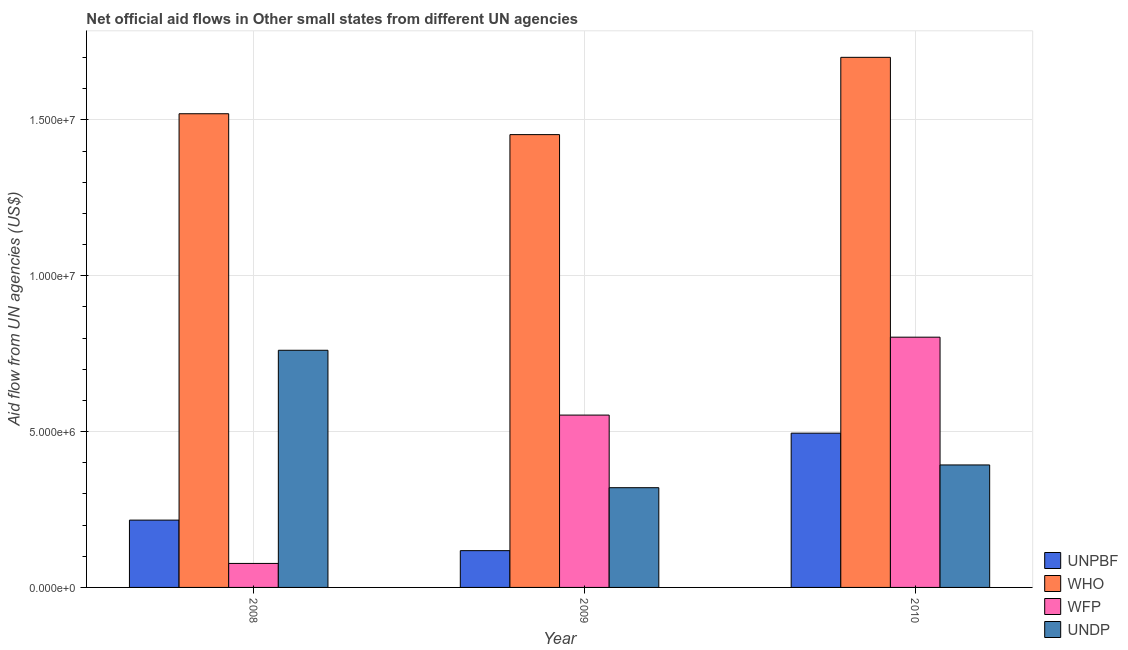Are the number of bars per tick equal to the number of legend labels?
Make the answer very short. Yes. Are the number of bars on each tick of the X-axis equal?
Provide a short and direct response. Yes. How many bars are there on the 2nd tick from the right?
Provide a short and direct response. 4. What is the label of the 3rd group of bars from the left?
Your response must be concise. 2010. What is the amount of aid given by wfp in 2010?
Make the answer very short. 8.03e+06. Across all years, what is the maximum amount of aid given by undp?
Provide a succinct answer. 7.61e+06. Across all years, what is the minimum amount of aid given by unpbf?
Ensure brevity in your answer.  1.18e+06. What is the total amount of aid given by who in the graph?
Offer a very short reply. 4.67e+07. What is the difference between the amount of aid given by undp in 2009 and that in 2010?
Ensure brevity in your answer.  -7.30e+05. What is the difference between the amount of aid given by unpbf in 2008 and the amount of aid given by wfp in 2010?
Keep it short and to the point. -2.79e+06. What is the average amount of aid given by wfp per year?
Keep it short and to the point. 4.78e+06. In the year 2009, what is the difference between the amount of aid given by who and amount of aid given by wfp?
Give a very brief answer. 0. What is the ratio of the amount of aid given by undp in 2008 to that in 2009?
Your answer should be very brief. 2.38. Is the amount of aid given by who in 2009 less than that in 2010?
Your answer should be very brief. Yes. Is the difference between the amount of aid given by wfp in 2009 and 2010 greater than the difference between the amount of aid given by who in 2009 and 2010?
Your answer should be very brief. No. What is the difference between the highest and the second highest amount of aid given by unpbf?
Your answer should be very brief. 2.79e+06. What is the difference between the highest and the lowest amount of aid given by unpbf?
Your answer should be very brief. 3.77e+06. In how many years, is the amount of aid given by undp greater than the average amount of aid given by undp taken over all years?
Provide a short and direct response. 1. What does the 1st bar from the left in 2010 represents?
Keep it short and to the point. UNPBF. What does the 2nd bar from the right in 2009 represents?
Your response must be concise. WFP. Is it the case that in every year, the sum of the amount of aid given by unpbf and amount of aid given by who is greater than the amount of aid given by wfp?
Keep it short and to the point. Yes. How many bars are there?
Offer a very short reply. 12. Are all the bars in the graph horizontal?
Your response must be concise. No. How many years are there in the graph?
Give a very brief answer. 3. Are the values on the major ticks of Y-axis written in scientific E-notation?
Your response must be concise. Yes. What is the title of the graph?
Offer a terse response. Net official aid flows in Other small states from different UN agencies. What is the label or title of the Y-axis?
Give a very brief answer. Aid flow from UN agencies (US$). What is the Aid flow from UN agencies (US$) in UNPBF in 2008?
Your answer should be compact. 2.16e+06. What is the Aid flow from UN agencies (US$) of WHO in 2008?
Give a very brief answer. 1.52e+07. What is the Aid flow from UN agencies (US$) of WFP in 2008?
Your answer should be compact. 7.70e+05. What is the Aid flow from UN agencies (US$) in UNDP in 2008?
Offer a terse response. 7.61e+06. What is the Aid flow from UN agencies (US$) of UNPBF in 2009?
Your answer should be compact. 1.18e+06. What is the Aid flow from UN agencies (US$) in WHO in 2009?
Your response must be concise. 1.45e+07. What is the Aid flow from UN agencies (US$) in WFP in 2009?
Provide a short and direct response. 5.53e+06. What is the Aid flow from UN agencies (US$) in UNDP in 2009?
Your answer should be compact. 3.20e+06. What is the Aid flow from UN agencies (US$) of UNPBF in 2010?
Keep it short and to the point. 4.95e+06. What is the Aid flow from UN agencies (US$) in WHO in 2010?
Make the answer very short. 1.70e+07. What is the Aid flow from UN agencies (US$) in WFP in 2010?
Offer a very short reply. 8.03e+06. What is the Aid flow from UN agencies (US$) of UNDP in 2010?
Your response must be concise. 3.93e+06. Across all years, what is the maximum Aid flow from UN agencies (US$) in UNPBF?
Keep it short and to the point. 4.95e+06. Across all years, what is the maximum Aid flow from UN agencies (US$) in WHO?
Your response must be concise. 1.70e+07. Across all years, what is the maximum Aid flow from UN agencies (US$) in WFP?
Offer a very short reply. 8.03e+06. Across all years, what is the maximum Aid flow from UN agencies (US$) in UNDP?
Offer a very short reply. 7.61e+06. Across all years, what is the minimum Aid flow from UN agencies (US$) of UNPBF?
Give a very brief answer. 1.18e+06. Across all years, what is the minimum Aid flow from UN agencies (US$) in WHO?
Keep it short and to the point. 1.45e+07. Across all years, what is the minimum Aid flow from UN agencies (US$) of WFP?
Offer a very short reply. 7.70e+05. Across all years, what is the minimum Aid flow from UN agencies (US$) in UNDP?
Offer a very short reply. 3.20e+06. What is the total Aid flow from UN agencies (US$) in UNPBF in the graph?
Your response must be concise. 8.29e+06. What is the total Aid flow from UN agencies (US$) of WHO in the graph?
Give a very brief answer. 4.67e+07. What is the total Aid flow from UN agencies (US$) in WFP in the graph?
Make the answer very short. 1.43e+07. What is the total Aid flow from UN agencies (US$) of UNDP in the graph?
Offer a terse response. 1.47e+07. What is the difference between the Aid flow from UN agencies (US$) in UNPBF in 2008 and that in 2009?
Keep it short and to the point. 9.80e+05. What is the difference between the Aid flow from UN agencies (US$) in WHO in 2008 and that in 2009?
Provide a succinct answer. 6.70e+05. What is the difference between the Aid flow from UN agencies (US$) in WFP in 2008 and that in 2009?
Your answer should be very brief. -4.76e+06. What is the difference between the Aid flow from UN agencies (US$) in UNDP in 2008 and that in 2009?
Provide a succinct answer. 4.41e+06. What is the difference between the Aid flow from UN agencies (US$) in UNPBF in 2008 and that in 2010?
Your answer should be very brief. -2.79e+06. What is the difference between the Aid flow from UN agencies (US$) of WHO in 2008 and that in 2010?
Ensure brevity in your answer.  -1.81e+06. What is the difference between the Aid flow from UN agencies (US$) in WFP in 2008 and that in 2010?
Your answer should be compact. -7.26e+06. What is the difference between the Aid flow from UN agencies (US$) in UNDP in 2008 and that in 2010?
Your answer should be compact. 3.68e+06. What is the difference between the Aid flow from UN agencies (US$) in UNPBF in 2009 and that in 2010?
Keep it short and to the point. -3.77e+06. What is the difference between the Aid flow from UN agencies (US$) in WHO in 2009 and that in 2010?
Ensure brevity in your answer.  -2.48e+06. What is the difference between the Aid flow from UN agencies (US$) of WFP in 2009 and that in 2010?
Provide a short and direct response. -2.50e+06. What is the difference between the Aid flow from UN agencies (US$) in UNDP in 2009 and that in 2010?
Provide a short and direct response. -7.30e+05. What is the difference between the Aid flow from UN agencies (US$) in UNPBF in 2008 and the Aid flow from UN agencies (US$) in WHO in 2009?
Give a very brief answer. -1.24e+07. What is the difference between the Aid flow from UN agencies (US$) of UNPBF in 2008 and the Aid flow from UN agencies (US$) of WFP in 2009?
Give a very brief answer. -3.37e+06. What is the difference between the Aid flow from UN agencies (US$) of UNPBF in 2008 and the Aid flow from UN agencies (US$) of UNDP in 2009?
Your response must be concise. -1.04e+06. What is the difference between the Aid flow from UN agencies (US$) of WHO in 2008 and the Aid flow from UN agencies (US$) of WFP in 2009?
Offer a very short reply. 9.67e+06. What is the difference between the Aid flow from UN agencies (US$) in WFP in 2008 and the Aid flow from UN agencies (US$) in UNDP in 2009?
Make the answer very short. -2.43e+06. What is the difference between the Aid flow from UN agencies (US$) in UNPBF in 2008 and the Aid flow from UN agencies (US$) in WHO in 2010?
Offer a terse response. -1.48e+07. What is the difference between the Aid flow from UN agencies (US$) of UNPBF in 2008 and the Aid flow from UN agencies (US$) of WFP in 2010?
Provide a succinct answer. -5.87e+06. What is the difference between the Aid flow from UN agencies (US$) of UNPBF in 2008 and the Aid flow from UN agencies (US$) of UNDP in 2010?
Make the answer very short. -1.77e+06. What is the difference between the Aid flow from UN agencies (US$) in WHO in 2008 and the Aid flow from UN agencies (US$) in WFP in 2010?
Offer a terse response. 7.17e+06. What is the difference between the Aid flow from UN agencies (US$) of WHO in 2008 and the Aid flow from UN agencies (US$) of UNDP in 2010?
Offer a very short reply. 1.13e+07. What is the difference between the Aid flow from UN agencies (US$) in WFP in 2008 and the Aid flow from UN agencies (US$) in UNDP in 2010?
Keep it short and to the point. -3.16e+06. What is the difference between the Aid flow from UN agencies (US$) in UNPBF in 2009 and the Aid flow from UN agencies (US$) in WHO in 2010?
Keep it short and to the point. -1.58e+07. What is the difference between the Aid flow from UN agencies (US$) in UNPBF in 2009 and the Aid flow from UN agencies (US$) in WFP in 2010?
Offer a terse response. -6.85e+06. What is the difference between the Aid flow from UN agencies (US$) of UNPBF in 2009 and the Aid flow from UN agencies (US$) of UNDP in 2010?
Provide a succinct answer. -2.75e+06. What is the difference between the Aid flow from UN agencies (US$) of WHO in 2009 and the Aid flow from UN agencies (US$) of WFP in 2010?
Your response must be concise. 6.50e+06. What is the difference between the Aid flow from UN agencies (US$) in WHO in 2009 and the Aid flow from UN agencies (US$) in UNDP in 2010?
Ensure brevity in your answer.  1.06e+07. What is the difference between the Aid flow from UN agencies (US$) in WFP in 2009 and the Aid flow from UN agencies (US$) in UNDP in 2010?
Provide a succinct answer. 1.60e+06. What is the average Aid flow from UN agencies (US$) of UNPBF per year?
Provide a short and direct response. 2.76e+06. What is the average Aid flow from UN agencies (US$) of WHO per year?
Make the answer very short. 1.56e+07. What is the average Aid flow from UN agencies (US$) of WFP per year?
Offer a very short reply. 4.78e+06. What is the average Aid flow from UN agencies (US$) in UNDP per year?
Keep it short and to the point. 4.91e+06. In the year 2008, what is the difference between the Aid flow from UN agencies (US$) of UNPBF and Aid flow from UN agencies (US$) of WHO?
Provide a short and direct response. -1.30e+07. In the year 2008, what is the difference between the Aid flow from UN agencies (US$) of UNPBF and Aid flow from UN agencies (US$) of WFP?
Your answer should be very brief. 1.39e+06. In the year 2008, what is the difference between the Aid flow from UN agencies (US$) in UNPBF and Aid flow from UN agencies (US$) in UNDP?
Your answer should be compact. -5.45e+06. In the year 2008, what is the difference between the Aid flow from UN agencies (US$) in WHO and Aid flow from UN agencies (US$) in WFP?
Make the answer very short. 1.44e+07. In the year 2008, what is the difference between the Aid flow from UN agencies (US$) in WHO and Aid flow from UN agencies (US$) in UNDP?
Offer a terse response. 7.59e+06. In the year 2008, what is the difference between the Aid flow from UN agencies (US$) of WFP and Aid flow from UN agencies (US$) of UNDP?
Ensure brevity in your answer.  -6.84e+06. In the year 2009, what is the difference between the Aid flow from UN agencies (US$) of UNPBF and Aid flow from UN agencies (US$) of WHO?
Provide a short and direct response. -1.34e+07. In the year 2009, what is the difference between the Aid flow from UN agencies (US$) in UNPBF and Aid flow from UN agencies (US$) in WFP?
Your answer should be very brief. -4.35e+06. In the year 2009, what is the difference between the Aid flow from UN agencies (US$) of UNPBF and Aid flow from UN agencies (US$) of UNDP?
Give a very brief answer. -2.02e+06. In the year 2009, what is the difference between the Aid flow from UN agencies (US$) of WHO and Aid flow from UN agencies (US$) of WFP?
Your answer should be compact. 9.00e+06. In the year 2009, what is the difference between the Aid flow from UN agencies (US$) of WHO and Aid flow from UN agencies (US$) of UNDP?
Offer a very short reply. 1.13e+07. In the year 2009, what is the difference between the Aid flow from UN agencies (US$) of WFP and Aid flow from UN agencies (US$) of UNDP?
Your response must be concise. 2.33e+06. In the year 2010, what is the difference between the Aid flow from UN agencies (US$) of UNPBF and Aid flow from UN agencies (US$) of WHO?
Keep it short and to the point. -1.21e+07. In the year 2010, what is the difference between the Aid flow from UN agencies (US$) in UNPBF and Aid flow from UN agencies (US$) in WFP?
Keep it short and to the point. -3.08e+06. In the year 2010, what is the difference between the Aid flow from UN agencies (US$) of UNPBF and Aid flow from UN agencies (US$) of UNDP?
Your answer should be compact. 1.02e+06. In the year 2010, what is the difference between the Aid flow from UN agencies (US$) of WHO and Aid flow from UN agencies (US$) of WFP?
Your answer should be compact. 8.98e+06. In the year 2010, what is the difference between the Aid flow from UN agencies (US$) in WHO and Aid flow from UN agencies (US$) in UNDP?
Provide a succinct answer. 1.31e+07. In the year 2010, what is the difference between the Aid flow from UN agencies (US$) of WFP and Aid flow from UN agencies (US$) of UNDP?
Ensure brevity in your answer.  4.10e+06. What is the ratio of the Aid flow from UN agencies (US$) of UNPBF in 2008 to that in 2009?
Your response must be concise. 1.83. What is the ratio of the Aid flow from UN agencies (US$) of WHO in 2008 to that in 2009?
Offer a terse response. 1.05. What is the ratio of the Aid flow from UN agencies (US$) of WFP in 2008 to that in 2009?
Your response must be concise. 0.14. What is the ratio of the Aid flow from UN agencies (US$) of UNDP in 2008 to that in 2009?
Your answer should be very brief. 2.38. What is the ratio of the Aid flow from UN agencies (US$) of UNPBF in 2008 to that in 2010?
Keep it short and to the point. 0.44. What is the ratio of the Aid flow from UN agencies (US$) in WHO in 2008 to that in 2010?
Give a very brief answer. 0.89. What is the ratio of the Aid flow from UN agencies (US$) of WFP in 2008 to that in 2010?
Offer a very short reply. 0.1. What is the ratio of the Aid flow from UN agencies (US$) of UNDP in 2008 to that in 2010?
Your answer should be very brief. 1.94. What is the ratio of the Aid flow from UN agencies (US$) in UNPBF in 2009 to that in 2010?
Provide a short and direct response. 0.24. What is the ratio of the Aid flow from UN agencies (US$) in WHO in 2009 to that in 2010?
Keep it short and to the point. 0.85. What is the ratio of the Aid flow from UN agencies (US$) in WFP in 2009 to that in 2010?
Your response must be concise. 0.69. What is the ratio of the Aid flow from UN agencies (US$) in UNDP in 2009 to that in 2010?
Keep it short and to the point. 0.81. What is the difference between the highest and the second highest Aid flow from UN agencies (US$) of UNPBF?
Your answer should be compact. 2.79e+06. What is the difference between the highest and the second highest Aid flow from UN agencies (US$) in WHO?
Offer a very short reply. 1.81e+06. What is the difference between the highest and the second highest Aid flow from UN agencies (US$) of WFP?
Ensure brevity in your answer.  2.50e+06. What is the difference between the highest and the second highest Aid flow from UN agencies (US$) in UNDP?
Your answer should be very brief. 3.68e+06. What is the difference between the highest and the lowest Aid flow from UN agencies (US$) of UNPBF?
Your response must be concise. 3.77e+06. What is the difference between the highest and the lowest Aid flow from UN agencies (US$) in WHO?
Your answer should be very brief. 2.48e+06. What is the difference between the highest and the lowest Aid flow from UN agencies (US$) of WFP?
Provide a short and direct response. 7.26e+06. What is the difference between the highest and the lowest Aid flow from UN agencies (US$) of UNDP?
Ensure brevity in your answer.  4.41e+06. 